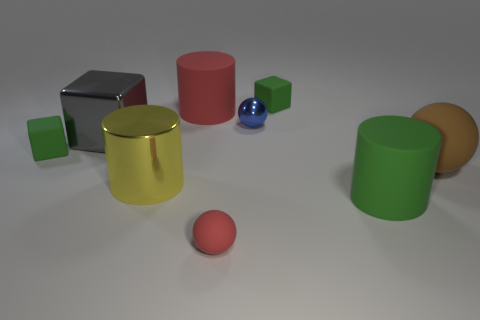Are there any tiny matte cubes that have the same color as the tiny rubber sphere?
Give a very brief answer. No. How many matte objects are to the right of the big cylinder that is behind the big brown rubber sphere?
Ensure brevity in your answer.  4. Is the number of blue spheres greater than the number of big blue matte objects?
Provide a succinct answer. Yes. Are the big yellow thing and the large green object made of the same material?
Ensure brevity in your answer.  No. Are there an equal number of rubber spheres that are in front of the brown matte sphere and large green cylinders?
Provide a short and direct response. Yes. What number of other big things are the same material as the large green object?
Your answer should be very brief. 2. Is the number of red matte cylinders less than the number of large purple metallic balls?
Your response must be concise. No. There is a tiny matte block right of the big metal cube; does it have the same color as the big shiny cylinder?
Make the answer very short. No. There is a big gray metallic object that is left of the matte thing that is right of the large green cylinder; how many brown balls are to the right of it?
Provide a short and direct response. 1. How many gray shiny objects are behind the large red thing?
Your answer should be compact. 0. 